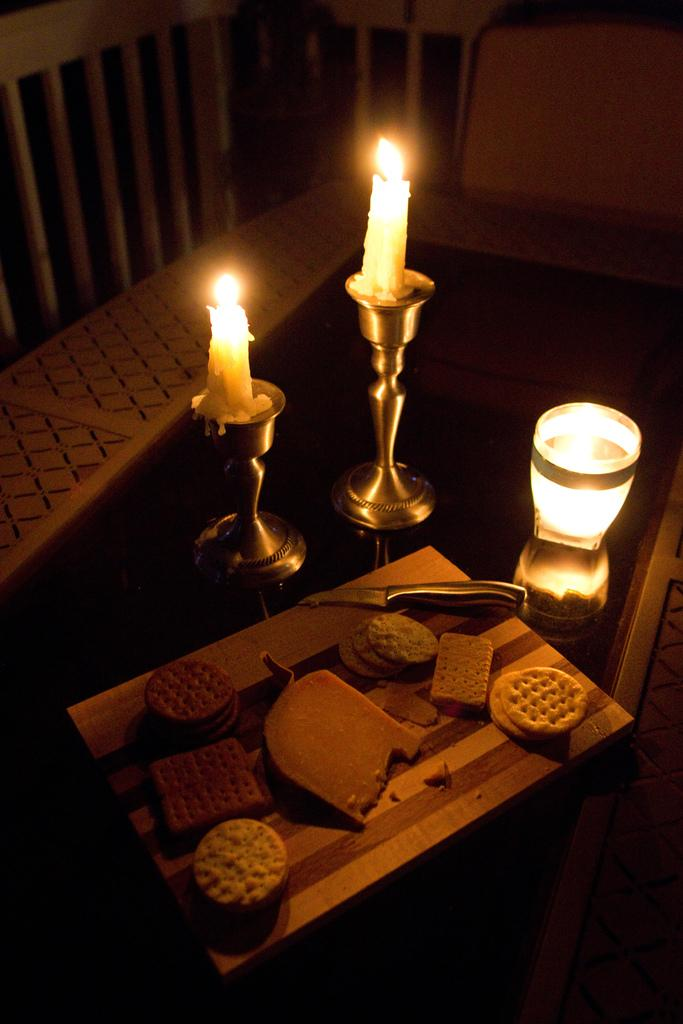What type of food items can be seen in the image? There are biscuits and bread in the image. What object might be used for cutting or spreading in the image? There is a knife in the image. What objects might be used for lighting or decoration in the image? There are candles in the image. Where are all the objects located in the image? All objects are on a table. What type of verse can be seen written on the bread in the image? There is no verse written on the bread in the image; it is just a piece of bread. 